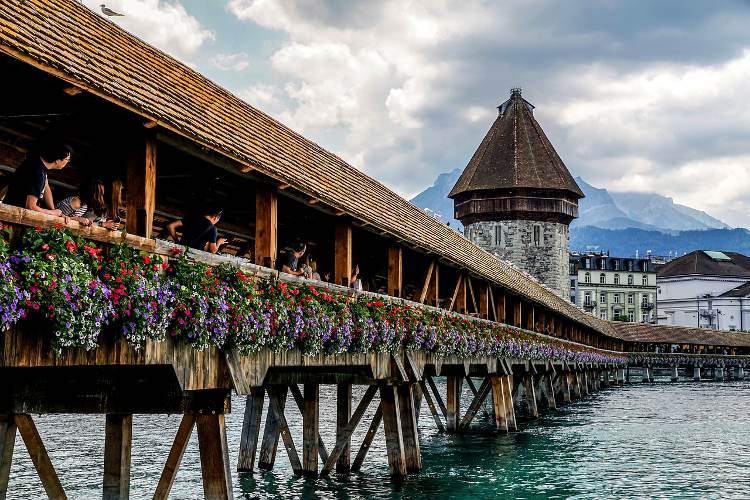What do you think is going on in this snapshot? This image features the renowned Chapel Bridge in Lucerne, Switzerland, an iconic wooden structure with a roof that stretches across the Reuss River. The stone Water Tower, a prominent part of the bridge, stands majestically to the right. The bridge is beautifully decorated with vibrant flowers, adding a touch of color to the rustic wooden architecture. The perspective shows the length of the bridge and the tower, with the stunning Swiss Alps and a picturesque blue sky with clouds in the background. The scene captures the peaceful blend of nature and historical architecture, making it a favorite spot for tourists. 